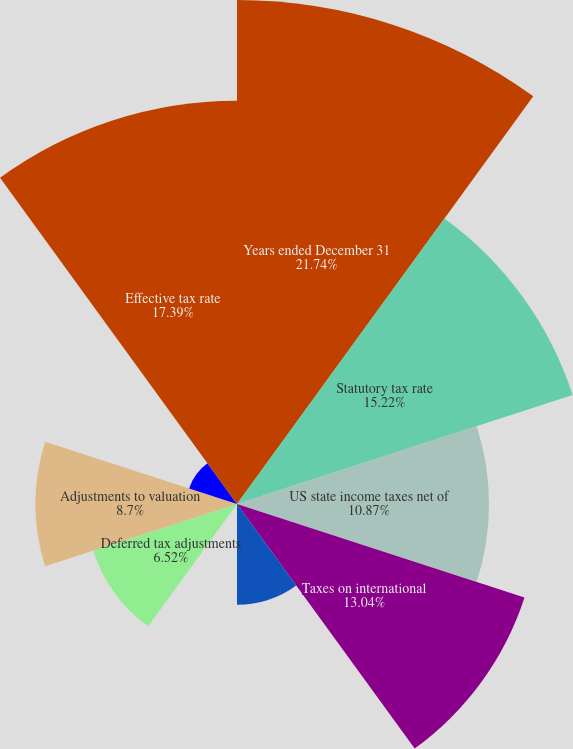Convert chart. <chart><loc_0><loc_0><loc_500><loc_500><pie_chart><fcel>Years ended December 31<fcel>Statutory tax rate<fcel>US state income taxes net of<fcel>Taxes on international<fcel>Nondeductible expenses<fcel>Adjustments to prior year tax<fcel>Deferred tax adjustments<fcel>Adjustments to valuation<fcel>Change in uncertain tax<fcel>Effective tax rate<nl><fcel>21.74%<fcel>15.22%<fcel>10.87%<fcel>13.04%<fcel>4.35%<fcel>0.0%<fcel>6.52%<fcel>8.7%<fcel>2.17%<fcel>17.39%<nl></chart> 